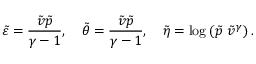Convert formula to latex. <formula><loc_0><loc_0><loc_500><loc_500>\tilde { \varepsilon } = \frac { \tilde { v } \tilde { p } } { \gamma - 1 } , \quad \tilde { \theta } = \frac { \tilde { v } \tilde { p } } { \gamma - 1 } , \quad \tilde { \eta } = \log \left ( \tilde { p } \ \tilde { v } ^ { \gamma } \right ) .</formula> 